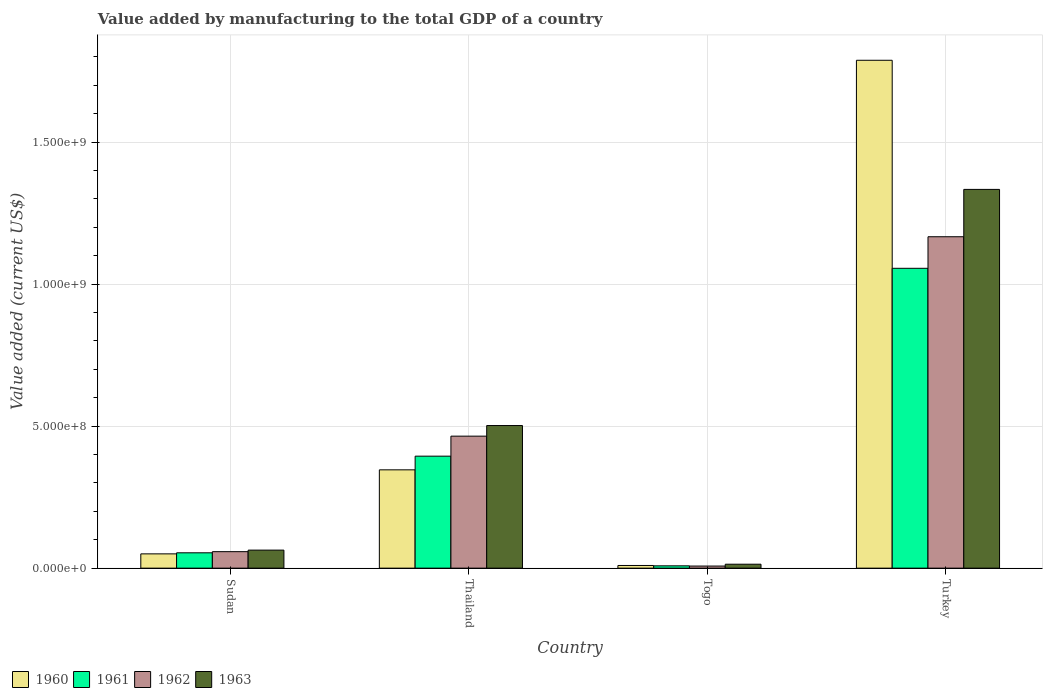How many different coloured bars are there?
Offer a very short reply. 4. Are the number of bars on each tick of the X-axis equal?
Provide a succinct answer. Yes. How many bars are there on the 3rd tick from the left?
Provide a succinct answer. 4. What is the label of the 1st group of bars from the left?
Give a very brief answer. Sudan. In how many cases, is the number of bars for a given country not equal to the number of legend labels?
Keep it short and to the point. 0. What is the value added by manufacturing to the total GDP in 1963 in Togo?
Your response must be concise. 1.39e+07. Across all countries, what is the maximum value added by manufacturing to the total GDP in 1960?
Offer a terse response. 1.79e+09. Across all countries, what is the minimum value added by manufacturing to the total GDP in 1963?
Provide a short and direct response. 1.39e+07. In which country was the value added by manufacturing to the total GDP in 1961 minimum?
Offer a very short reply. Togo. What is the total value added by manufacturing to the total GDP in 1961 in the graph?
Make the answer very short. 1.51e+09. What is the difference between the value added by manufacturing to the total GDP in 1961 in Sudan and that in Togo?
Make the answer very short. 4.58e+07. What is the difference between the value added by manufacturing to the total GDP in 1962 in Sudan and the value added by manufacturing to the total GDP in 1961 in Turkey?
Your answer should be compact. -9.98e+08. What is the average value added by manufacturing to the total GDP in 1960 per country?
Your response must be concise. 5.48e+08. What is the difference between the value added by manufacturing to the total GDP of/in 1963 and value added by manufacturing to the total GDP of/in 1961 in Turkey?
Provide a succinct answer. 2.78e+08. What is the ratio of the value added by manufacturing to the total GDP in 1960 in Sudan to that in Togo?
Make the answer very short. 5.36. What is the difference between the highest and the second highest value added by manufacturing to the total GDP in 1962?
Offer a very short reply. 1.11e+09. What is the difference between the highest and the lowest value added by manufacturing to the total GDP in 1960?
Ensure brevity in your answer.  1.78e+09. In how many countries, is the value added by manufacturing to the total GDP in 1960 greater than the average value added by manufacturing to the total GDP in 1960 taken over all countries?
Your answer should be compact. 1. Is the sum of the value added by manufacturing to the total GDP in 1961 in Sudan and Thailand greater than the maximum value added by manufacturing to the total GDP in 1962 across all countries?
Your response must be concise. No. Is it the case that in every country, the sum of the value added by manufacturing to the total GDP in 1961 and value added by manufacturing to the total GDP in 1962 is greater than the sum of value added by manufacturing to the total GDP in 1963 and value added by manufacturing to the total GDP in 1960?
Provide a short and direct response. No. What does the 1st bar from the left in Sudan represents?
Provide a succinct answer. 1960. What does the 2nd bar from the right in Turkey represents?
Your answer should be compact. 1962. Is it the case that in every country, the sum of the value added by manufacturing to the total GDP in 1962 and value added by manufacturing to the total GDP in 1961 is greater than the value added by manufacturing to the total GDP in 1960?
Keep it short and to the point. Yes. Are the values on the major ticks of Y-axis written in scientific E-notation?
Make the answer very short. Yes. Does the graph contain any zero values?
Your answer should be very brief. No. How many legend labels are there?
Offer a terse response. 4. How are the legend labels stacked?
Offer a terse response. Horizontal. What is the title of the graph?
Give a very brief answer. Value added by manufacturing to the total GDP of a country. Does "1977" appear as one of the legend labels in the graph?
Ensure brevity in your answer.  No. What is the label or title of the X-axis?
Offer a very short reply. Country. What is the label or title of the Y-axis?
Ensure brevity in your answer.  Value added (current US$). What is the Value added (current US$) of 1960 in Sudan?
Your answer should be very brief. 5.03e+07. What is the Value added (current US$) of 1961 in Sudan?
Make the answer very short. 5.40e+07. What is the Value added (current US$) of 1962 in Sudan?
Keep it short and to the point. 5.80e+07. What is the Value added (current US$) of 1963 in Sudan?
Offer a very short reply. 6.35e+07. What is the Value added (current US$) of 1960 in Thailand?
Keep it short and to the point. 3.46e+08. What is the Value added (current US$) in 1961 in Thailand?
Your answer should be very brief. 3.94e+08. What is the Value added (current US$) in 1962 in Thailand?
Offer a very short reply. 4.65e+08. What is the Value added (current US$) of 1963 in Thailand?
Your answer should be compact. 5.02e+08. What is the Value added (current US$) in 1960 in Togo?
Give a very brief answer. 9.38e+06. What is the Value added (current US$) of 1961 in Togo?
Give a very brief answer. 8.15e+06. What is the Value added (current US$) in 1962 in Togo?
Your response must be concise. 7.35e+06. What is the Value added (current US$) of 1963 in Togo?
Offer a terse response. 1.39e+07. What is the Value added (current US$) in 1960 in Turkey?
Ensure brevity in your answer.  1.79e+09. What is the Value added (current US$) of 1961 in Turkey?
Your answer should be very brief. 1.06e+09. What is the Value added (current US$) of 1962 in Turkey?
Offer a very short reply. 1.17e+09. What is the Value added (current US$) of 1963 in Turkey?
Provide a short and direct response. 1.33e+09. Across all countries, what is the maximum Value added (current US$) in 1960?
Provide a short and direct response. 1.79e+09. Across all countries, what is the maximum Value added (current US$) in 1961?
Your answer should be compact. 1.06e+09. Across all countries, what is the maximum Value added (current US$) in 1962?
Ensure brevity in your answer.  1.17e+09. Across all countries, what is the maximum Value added (current US$) in 1963?
Provide a short and direct response. 1.33e+09. Across all countries, what is the minimum Value added (current US$) of 1960?
Provide a short and direct response. 9.38e+06. Across all countries, what is the minimum Value added (current US$) of 1961?
Offer a very short reply. 8.15e+06. Across all countries, what is the minimum Value added (current US$) of 1962?
Offer a terse response. 7.35e+06. Across all countries, what is the minimum Value added (current US$) of 1963?
Your answer should be compact. 1.39e+07. What is the total Value added (current US$) of 1960 in the graph?
Make the answer very short. 2.19e+09. What is the total Value added (current US$) of 1961 in the graph?
Keep it short and to the point. 1.51e+09. What is the total Value added (current US$) in 1962 in the graph?
Give a very brief answer. 1.70e+09. What is the total Value added (current US$) in 1963 in the graph?
Offer a terse response. 1.91e+09. What is the difference between the Value added (current US$) of 1960 in Sudan and that in Thailand?
Give a very brief answer. -2.96e+08. What is the difference between the Value added (current US$) of 1961 in Sudan and that in Thailand?
Offer a very short reply. -3.40e+08. What is the difference between the Value added (current US$) of 1962 in Sudan and that in Thailand?
Keep it short and to the point. -4.07e+08. What is the difference between the Value added (current US$) of 1963 in Sudan and that in Thailand?
Provide a short and direct response. -4.39e+08. What is the difference between the Value added (current US$) of 1960 in Sudan and that in Togo?
Your response must be concise. 4.09e+07. What is the difference between the Value added (current US$) in 1961 in Sudan and that in Togo?
Keep it short and to the point. 4.58e+07. What is the difference between the Value added (current US$) of 1962 in Sudan and that in Togo?
Your answer should be very brief. 5.07e+07. What is the difference between the Value added (current US$) in 1963 in Sudan and that in Togo?
Offer a very short reply. 4.96e+07. What is the difference between the Value added (current US$) in 1960 in Sudan and that in Turkey?
Offer a very short reply. -1.74e+09. What is the difference between the Value added (current US$) of 1961 in Sudan and that in Turkey?
Provide a succinct answer. -1.00e+09. What is the difference between the Value added (current US$) of 1962 in Sudan and that in Turkey?
Provide a succinct answer. -1.11e+09. What is the difference between the Value added (current US$) in 1963 in Sudan and that in Turkey?
Ensure brevity in your answer.  -1.27e+09. What is the difference between the Value added (current US$) of 1960 in Thailand and that in Togo?
Your answer should be very brief. 3.37e+08. What is the difference between the Value added (current US$) of 1961 in Thailand and that in Togo?
Provide a short and direct response. 3.86e+08. What is the difference between the Value added (current US$) of 1962 in Thailand and that in Togo?
Your response must be concise. 4.57e+08. What is the difference between the Value added (current US$) of 1963 in Thailand and that in Togo?
Give a very brief answer. 4.88e+08. What is the difference between the Value added (current US$) of 1960 in Thailand and that in Turkey?
Make the answer very short. -1.44e+09. What is the difference between the Value added (current US$) of 1961 in Thailand and that in Turkey?
Your answer should be compact. -6.61e+08. What is the difference between the Value added (current US$) of 1962 in Thailand and that in Turkey?
Make the answer very short. -7.02e+08. What is the difference between the Value added (current US$) of 1963 in Thailand and that in Turkey?
Provide a succinct answer. -8.31e+08. What is the difference between the Value added (current US$) of 1960 in Togo and that in Turkey?
Your answer should be compact. -1.78e+09. What is the difference between the Value added (current US$) in 1961 in Togo and that in Turkey?
Your response must be concise. -1.05e+09. What is the difference between the Value added (current US$) of 1962 in Togo and that in Turkey?
Keep it short and to the point. -1.16e+09. What is the difference between the Value added (current US$) of 1963 in Togo and that in Turkey?
Give a very brief answer. -1.32e+09. What is the difference between the Value added (current US$) of 1960 in Sudan and the Value added (current US$) of 1961 in Thailand?
Ensure brevity in your answer.  -3.44e+08. What is the difference between the Value added (current US$) in 1960 in Sudan and the Value added (current US$) in 1962 in Thailand?
Offer a very short reply. -4.14e+08. What is the difference between the Value added (current US$) in 1960 in Sudan and the Value added (current US$) in 1963 in Thailand?
Ensure brevity in your answer.  -4.52e+08. What is the difference between the Value added (current US$) in 1961 in Sudan and the Value added (current US$) in 1962 in Thailand?
Your answer should be compact. -4.11e+08. What is the difference between the Value added (current US$) of 1961 in Sudan and the Value added (current US$) of 1963 in Thailand?
Provide a succinct answer. -4.48e+08. What is the difference between the Value added (current US$) of 1962 in Sudan and the Value added (current US$) of 1963 in Thailand?
Give a very brief answer. -4.44e+08. What is the difference between the Value added (current US$) in 1960 in Sudan and the Value added (current US$) in 1961 in Togo?
Keep it short and to the point. 4.21e+07. What is the difference between the Value added (current US$) in 1960 in Sudan and the Value added (current US$) in 1962 in Togo?
Your response must be concise. 4.29e+07. What is the difference between the Value added (current US$) in 1960 in Sudan and the Value added (current US$) in 1963 in Togo?
Your answer should be compact. 3.64e+07. What is the difference between the Value added (current US$) in 1961 in Sudan and the Value added (current US$) in 1962 in Togo?
Provide a short and direct response. 4.66e+07. What is the difference between the Value added (current US$) of 1961 in Sudan and the Value added (current US$) of 1963 in Togo?
Your answer should be very brief. 4.01e+07. What is the difference between the Value added (current US$) in 1962 in Sudan and the Value added (current US$) in 1963 in Togo?
Give a very brief answer. 4.41e+07. What is the difference between the Value added (current US$) in 1960 in Sudan and the Value added (current US$) in 1961 in Turkey?
Your response must be concise. -1.01e+09. What is the difference between the Value added (current US$) in 1960 in Sudan and the Value added (current US$) in 1962 in Turkey?
Offer a very short reply. -1.12e+09. What is the difference between the Value added (current US$) of 1960 in Sudan and the Value added (current US$) of 1963 in Turkey?
Keep it short and to the point. -1.28e+09. What is the difference between the Value added (current US$) of 1961 in Sudan and the Value added (current US$) of 1962 in Turkey?
Provide a succinct answer. -1.11e+09. What is the difference between the Value added (current US$) in 1961 in Sudan and the Value added (current US$) in 1963 in Turkey?
Keep it short and to the point. -1.28e+09. What is the difference between the Value added (current US$) in 1962 in Sudan and the Value added (current US$) in 1963 in Turkey?
Offer a very short reply. -1.28e+09. What is the difference between the Value added (current US$) of 1960 in Thailand and the Value added (current US$) of 1961 in Togo?
Ensure brevity in your answer.  3.38e+08. What is the difference between the Value added (current US$) in 1960 in Thailand and the Value added (current US$) in 1962 in Togo?
Your answer should be compact. 3.39e+08. What is the difference between the Value added (current US$) of 1960 in Thailand and the Value added (current US$) of 1963 in Togo?
Provide a short and direct response. 3.32e+08. What is the difference between the Value added (current US$) of 1961 in Thailand and the Value added (current US$) of 1962 in Togo?
Your answer should be compact. 3.87e+08. What is the difference between the Value added (current US$) in 1961 in Thailand and the Value added (current US$) in 1963 in Togo?
Provide a short and direct response. 3.80e+08. What is the difference between the Value added (current US$) in 1962 in Thailand and the Value added (current US$) in 1963 in Togo?
Ensure brevity in your answer.  4.51e+08. What is the difference between the Value added (current US$) in 1960 in Thailand and the Value added (current US$) in 1961 in Turkey?
Make the answer very short. -7.09e+08. What is the difference between the Value added (current US$) of 1960 in Thailand and the Value added (current US$) of 1962 in Turkey?
Offer a terse response. -8.21e+08. What is the difference between the Value added (current US$) in 1960 in Thailand and the Value added (current US$) in 1963 in Turkey?
Provide a short and direct response. -9.87e+08. What is the difference between the Value added (current US$) of 1961 in Thailand and the Value added (current US$) of 1962 in Turkey?
Offer a very short reply. -7.72e+08. What is the difference between the Value added (current US$) of 1961 in Thailand and the Value added (current US$) of 1963 in Turkey?
Offer a very short reply. -9.39e+08. What is the difference between the Value added (current US$) of 1962 in Thailand and the Value added (current US$) of 1963 in Turkey?
Your answer should be compact. -8.69e+08. What is the difference between the Value added (current US$) of 1960 in Togo and the Value added (current US$) of 1961 in Turkey?
Give a very brief answer. -1.05e+09. What is the difference between the Value added (current US$) in 1960 in Togo and the Value added (current US$) in 1962 in Turkey?
Your answer should be very brief. -1.16e+09. What is the difference between the Value added (current US$) of 1960 in Togo and the Value added (current US$) of 1963 in Turkey?
Offer a terse response. -1.32e+09. What is the difference between the Value added (current US$) of 1961 in Togo and the Value added (current US$) of 1962 in Turkey?
Make the answer very short. -1.16e+09. What is the difference between the Value added (current US$) of 1961 in Togo and the Value added (current US$) of 1963 in Turkey?
Your response must be concise. -1.33e+09. What is the difference between the Value added (current US$) of 1962 in Togo and the Value added (current US$) of 1963 in Turkey?
Provide a succinct answer. -1.33e+09. What is the average Value added (current US$) of 1960 per country?
Your answer should be very brief. 5.48e+08. What is the average Value added (current US$) in 1961 per country?
Offer a terse response. 3.78e+08. What is the average Value added (current US$) in 1962 per country?
Ensure brevity in your answer.  4.24e+08. What is the average Value added (current US$) in 1963 per country?
Make the answer very short. 4.78e+08. What is the difference between the Value added (current US$) of 1960 and Value added (current US$) of 1961 in Sudan?
Offer a terse response. -3.73e+06. What is the difference between the Value added (current US$) in 1960 and Value added (current US$) in 1962 in Sudan?
Offer a very short reply. -7.75e+06. What is the difference between the Value added (current US$) of 1960 and Value added (current US$) of 1963 in Sudan?
Make the answer very short. -1.32e+07. What is the difference between the Value added (current US$) of 1961 and Value added (current US$) of 1962 in Sudan?
Your answer should be compact. -4.02e+06. What is the difference between the Value added (current US$) of 1961 and Value added (current US$) of 1963 in Sudan?
Make the answer very short. -9.48e+06. What is the difference between the Value added (current US$) of 1962 and Value added (current US$) of 1963 in Sudan?
Your answer should be compact. -5.46e+06. What is the difference between the Value added (current US$) in 1960 and Value added (current US$) in 1961 in Thailand?
Your response must be concise. -4.81e+07. What is the difference between the Value added (current US$) of 1960 and Value added (current US$) of 1962 in Thailand?
Give a very brief answer. -1.19e+08. What is the difference between the Value added (current US$) in 1960 and Value added (current US$) in 1963 in Thailand?
Provide a short and direct response. -1.56e+08. What is the difference between the Value added (current US$) in 1961 and Value added (current US$) in 1962 in Thailand?
Make the answer very short. -7.05e+07. What is the difference between the Value added (current US$) of 1961 and Value added (current US$) of 1963 in Thailand?
Ensure brevity in your answer.  -1.08e+08. What is the difference between the Value added (current US$) of 1962 and Value added (current US$) of 1963 in Thailand?
Your answer should be very brief. -3.73e+07. What is the difference between the Value added (current US$) of 1960 and Value added (current US$) of 1961 in Togo?
Give a very brief answer. 1.23e+06. What is the difference between the Value added (current US$) in 1960 and Value added (current US$) in 1962 in Togo?
Your response must be concise. 2.03e+06. What is the difference between the Value added (current US$) of 1960 and Value added (current US$) of 1963 in Togo?
Provide a succinct answer. -4.50e+06. What is the difference between the Value added (current US$) of 1961 and Value added (current US$) of 1962 in Togo?
Your answer should be very brief. 8.08e+05. What is the difference between the Value added (current US$) in 1961 and Value added (current US$) in 1963 in Togo?
Give a very brief answer. -5.72e+06. What is the difference between the Value added (current US$) of 1962 and Value added (current US$) of 1963 in Togo?
Your response must be concise. -6.53e+06. What is the difference between the Value added (current US$) in 1960 and Value added (current US$) in 1961 in Turkey?
Ensure brevity in your answer.  7.32e+08. What is the difference between the Value added (current US$) of 1960 and Value added (current US$) of 1962 in Turkey?
Provide a succinct answer. 6.21e+08. What is the difference between the Value added (current US$) in 1960 and Value added (current US$) in 1963 in Turkey?
Provide a short and direct response. 4.55e+08. What is the difference between the Value added (current US$) in 1961 and Value added (current US$) in 1962 in Turkey?
Your answer should be very brief. -1.11e+08. What is the difference between the Value added (current US$) in 1961 and Value added (current US$) in 1963 in Turkey?
Your response must be concise. -2.78e+08. What is the difference between the Value added (current US$) in 1962 and Value added (current US$) in 1963 in Turkey?
Ensure brevity in your answer.  -1.67e+08. What is the ratio of the Value added (current US$) in 1960 in Sudan to that in Thailand?
Offer a very short reply. 0.15. What is the ratio of the Value added (current US$) in 1961 in Sudan to that in Thailand?
Make the answer very short. 0.14. What is the ratio of the Value added (current US$) of 1962 in Sudan to that in Thailand?
Your answer should be very brief. 0.12. What is the ratio of the Value added (current US$) in 1963 in Sudan to that in Thailand?
Offer a very short reply. 0.13. What is the ratio of the Value added (current US$) in 1960 in Sudan to that in Togo?
Offer a very short reply. 5.36. What is the ratio of the Value added (current US$) in 1961 in Sudan to that in Togo?
Ensure brevity in your answer.  6.62. What is the ratio of the Value added (current US$) in 1962 in Sudan to that in Togo?
Ensure brevity in your answer.  7.9. What is the ratio of the Value added (current US$) of 1963 in Sudan to that in Togo?
Your answer should be compact. 4.57. What is the ratio of the Value added (current US$) of 1960 in Sudan to that in Turkey?
Your response must be concise. 0.03. What is the ratio of the Value added (current US$) in 1961 in Sudan to that in Turkey?
Provide a short and direct response. 0.05. What is the ratio of the Value added (current US$) of 1962 in Sudan to that in Turkey?
Provide a short and direct response. 0.05. What is the ratio of the Value added (current US$) in 1963 in Sudan to that in Turkey?
Give a very brief answer. 0.05. What is the ratio of the Value added (current US$) of 1960 in Thailand to that in Togo?
Offer a terse response. 36.9. What is the ratio of the Value added (current US$) in 1961 in Thailand to that in Togo?
Provide a succinct answer. 48.34. What is the ratio of the Value added (current US$) of 1962 in Thailand to that in Togo?
Provide a short and direct response. 63.26. What is the ratio of the Value added (current US$) in 1963 in Thailand to that in Togo?
Your response must be concise. 36.18. What is the ratio of the Value added (current US$) in 1960 in Thailand to that in Turkey?
Provide a short and direct response. 0.19. What is the ratio of the Value added (current US$) of 1961 in Thailand to that in Turkey?
Offer a very short reply. 0.37. What is the ratio of the Value added (current US$) in 1962 in Thailand to that in Turkey?
Provide a succinct answer. 0.4. What is the ratio of the Value added (current US$) of 1963 in Thailand to that in Turkey?
Your response must be concise. 0.38. What is the ratio of the Value added (current US$) of 1960 in Togo to that in Turkey?
Your response must be concise. 0.01. What is the ratio of the Value added (current US$) in 1961 in Togo to that in Turkey?
Ensure brevity in your answer.  0.01. What is the ratio of the Value added (current US$) of 1962 in Togo to that in Turkey?
Provide a short and direct response. 0.01. What is the ratio of the Value added (current US$) of 1963 in Togo to that in Turkey?
Your response must be concise. 0.01. What is the difference between the highest and the second highest Value added (current US$) in 1960?
Ensure brevity in your answer.  1.44e+09. What is the difference between the highest and the second highest Value added (current US$) in 1961?
Your answer should be compact. 6.61e+08. What is the difference between the highest and the second highest Value added (current US$) of 1962?
Provide a succinct answer. 7.02e+08. What is the difference between the highest and the second highest Value added (current US$) in 1963?
Keep it short and to the point. 8.31e+08. What is the difference between the highest and the lowest Value added (current US$) of 1960?
Keep it short and to the point. 1.78e+09. What is the difference between the highest and the lowest Value added (current US$) in 1961?
Offer a very short reply. 1.05e+09. What is the difference between the highest and the lowest Value added (current US$) in 1962?
Provide a succinct answer. 1.16e+09. What is the difference between the highest and the lowest Value added (current US$) in 1963?
Give a very brief answer. 1.32e+09. 